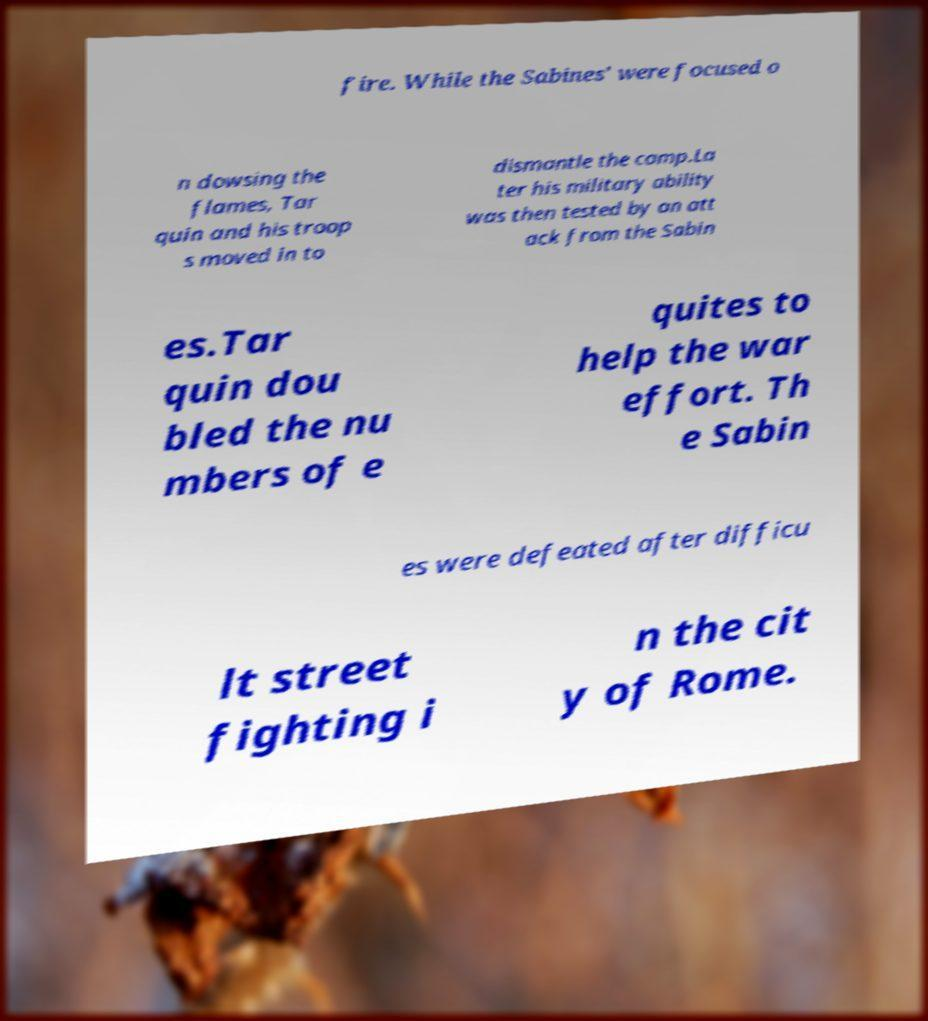Can you read and provide the text displayed in the image?This photo seems to have some interesting text. Can you extract and type it out for me? fire. While the Sabines' were focused o n dowsing the flames, Tar quin and his troop s moved in to dismantle the camp.La ter his military ability was then tested by an att ack from the Sabin es.Tar quin dou bled the nu mbers of e quites to help the war effort. Th e Sabin es were defeated after difficu lt street fighting i n the cit y of Rome. 